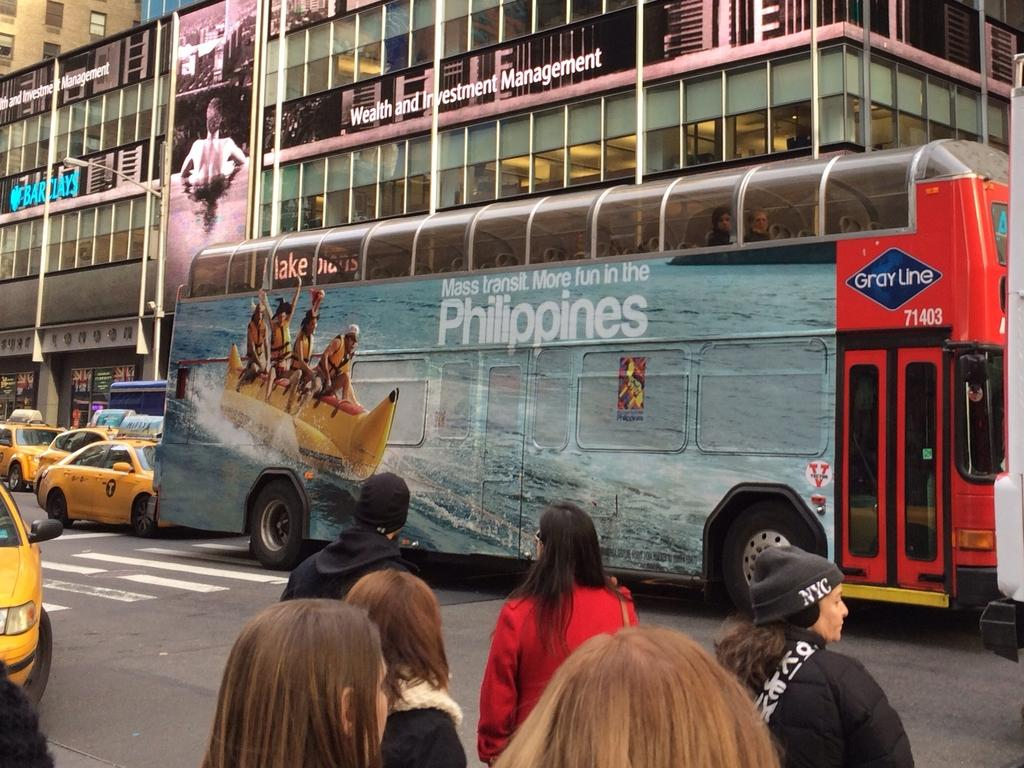<image>
Provide a brief description of the given image. A double decker bus sponsored by the Phillipines drives through the street. 